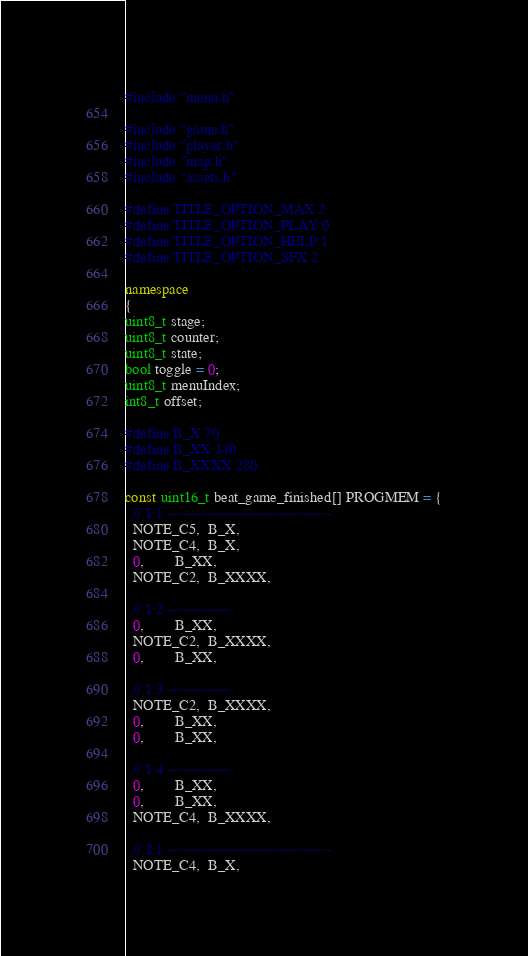Convert code to text. <code><loc_0><loc_0><loc_500><loc_500><_C++_>#include "menu.h"

#include "game.h"
#include "player.h"
#include "map.h"
#include "assets.h"

#define TITLE_OPTION_MAX 2
#define TITLE_OPTION_PLAY 0
#define TITLE_OPTION_HELP 1
#define TITLE_OPTION_SFX 2

namespace
{
uint8_t stage;
uint8_t counter;
uint8_t state;
bool toggle = 0;
uint8_t menuIndex;
int8_t offset;

#define B_X 70
#define B_XX 140
#define B_XXXX 280

const uint16_t beat_game_finished[] PROGMEM = {
  // 1:1 ----------------------------------
  NOTE_C5,  B_X,
  NOTE_C4,  B_X,
  0,        B_XX,
  NOTE_C2,  B_XXXX,

  // 1:2 -------------
  0,        B_XX,
  NOTE_C2,  B_XXXX,
  0,        B_XX,

  // 1:3 -------------
  NOTE_C2,  B_XXXX,
  0,        B_XX,
  0,        B_XX,

  // 1:4 -------------
  0,        B_XX,
  0,        B_XX,
  NOTE_C4,  B_XXXX,

  // 2:1 ----------------------------------
  NOTE_C4,  B_X,</code> 